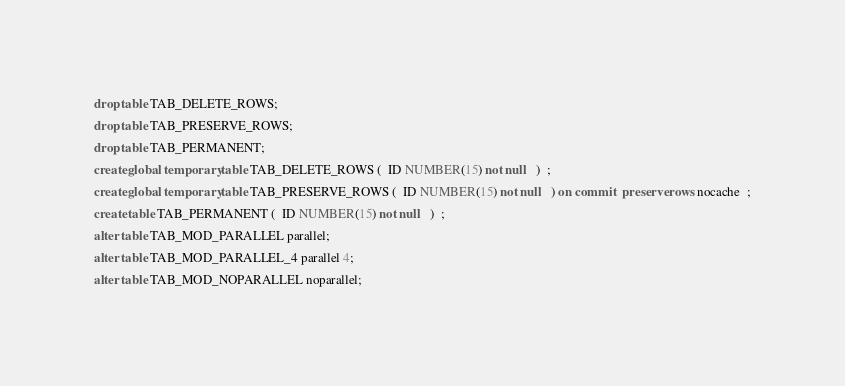Convert code to text. <code><loc_0><loc_0><loc_500><loc_500><_SQL_>drop table TAB_DELETE_ROWS;
drop table TAB_PRESERVE_ROWS;
drop table TAB_PERMANENT;
create global temporary table TAB_DELETE_ROWS (  ID NUMBER(15) not null   )  ;
create global temporary table TAB_PRESERVE_ROWS (  ID NUMBER(15) not null   ) on commit  preserve rows nocache  ;
create table TAB_PERMANENT (  ID NUMBER(15) not null   )  ;
alter table TAB_MOD_PARALLEL parallel;
alter table TAB_MOD_PARALLEL_4 parallel 4;
alter table TAB_MOD_NOPARALLEL noparallel;
</code> 